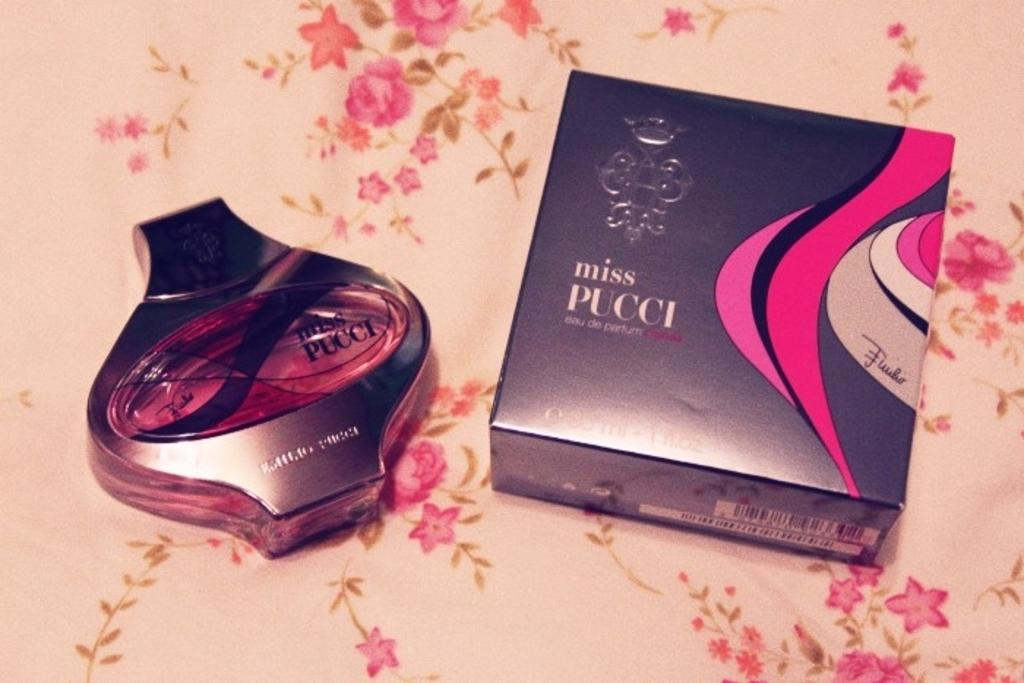<image>
Create a compact narrative representing the image presented. Box and perfume bottle of Miss Pucci on a cloth. 